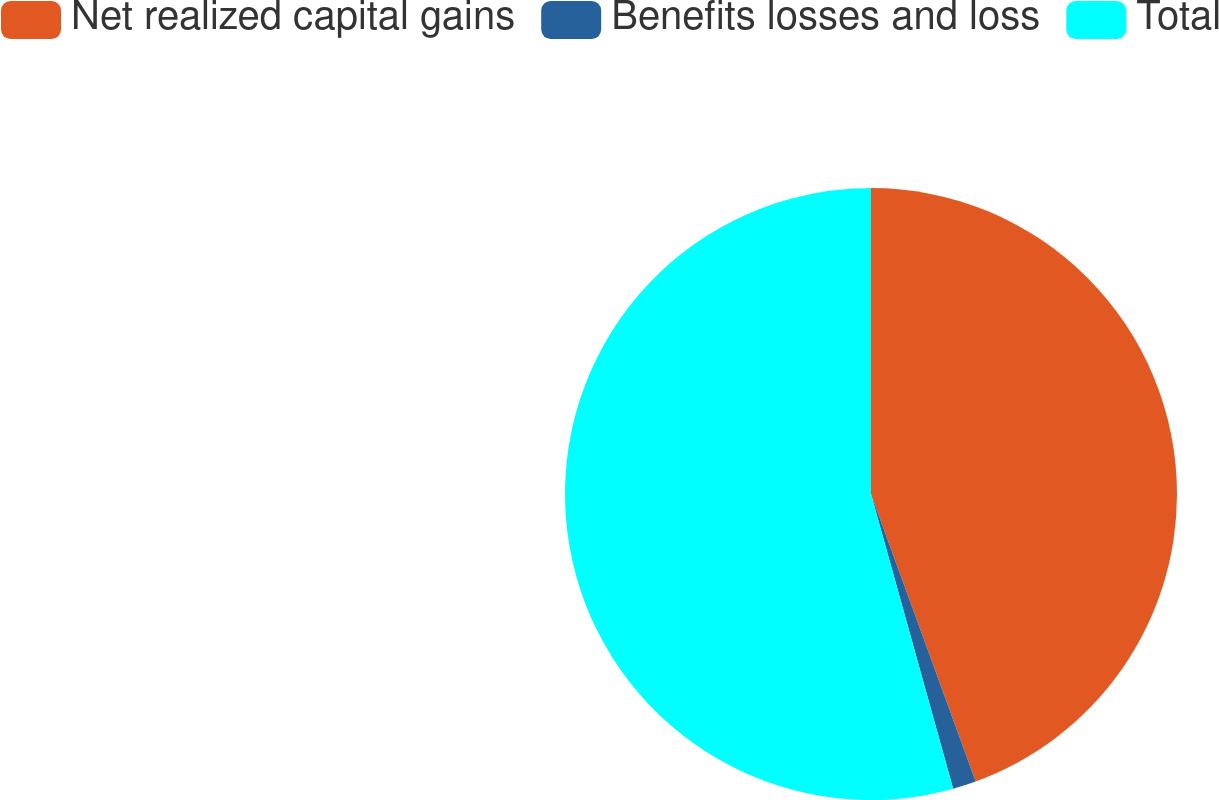<chart> <loc_0><loc_0><loc_500><loc_500><pie_chart><fcel>Net realized capital gains<fcel>Benefits losses and loss<fcel>Total<nl><fcel>44.44%<fcel>1.23%<fcel>54.32%<nl></chart> 